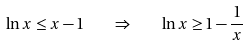Convert formula to latex. <formula><loc_0><loc_0><loc_500><loc_500>\ln x \leq x - 1 \quad \Rightarrow \quad \ln x \geq 1 - \frac { 1 } { x }</formula> 